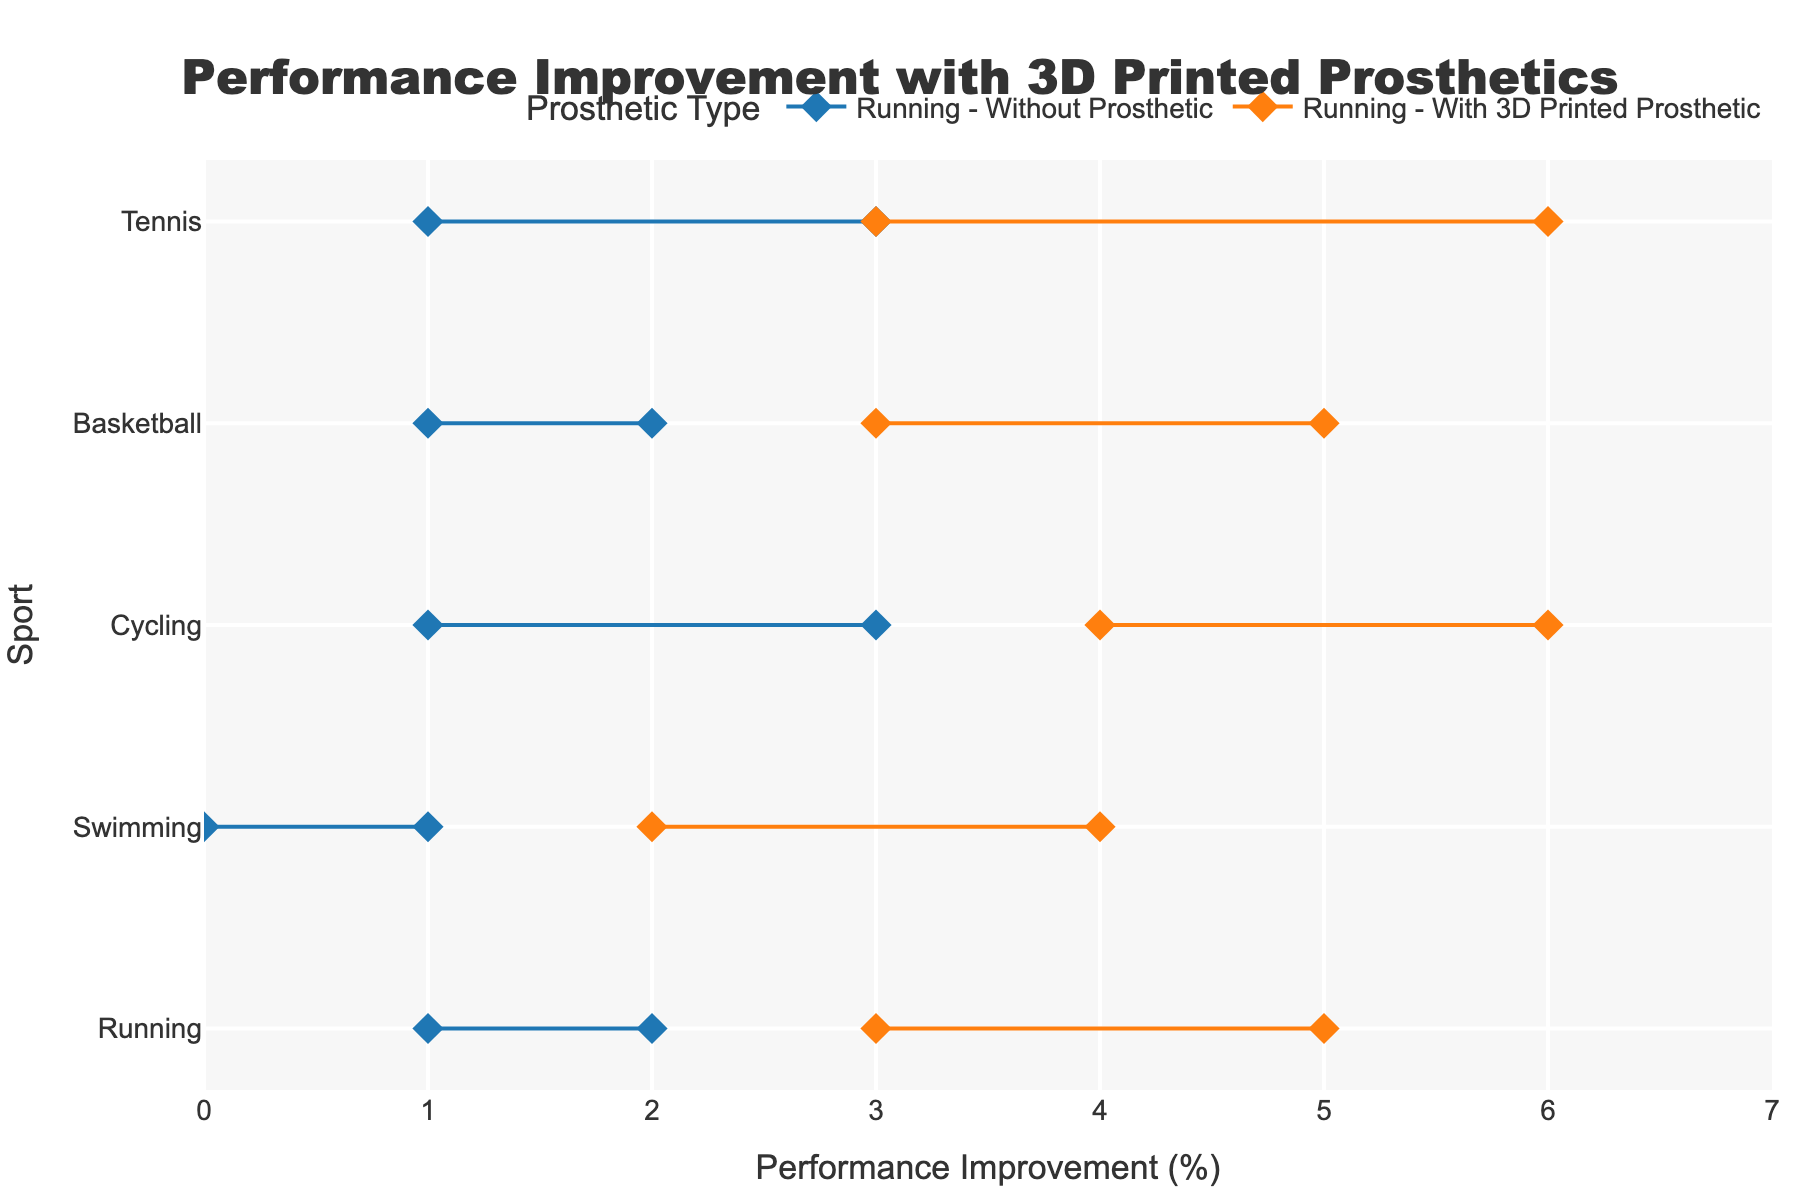What is the title of the figure? The title of the figure is usually located at the top center and provides a summary of what the data represents. In this case, it reads "Performance Improvement with 3D Printed Prosthetics".
Answer: Performance Improvement with 3D Printed Prosthetics What sports are shown in the figure? By looking at the y-axis, we can list all the sports shown. They include Running, Swimming, Cycling, Basketball, and Tennis.
Answer: Running, Swimming, Cycling, Basketball, Tennis For running, what is the range of performance improvement for athletes with 3D printed prosthetics? For Running, locate the orange line with diamond markers on the x-axis corresponding to "With 3D Printed Prosthetic". It spans from 3 to 5.
Answer: 3-5 Which sport shows the least improvement without prosthetics? Find the sport with the smallest range by looking at the blue lines. Swimming shows a range from 0 to 1, which is the smallest.
Answer: Swimming How does the performance improvement for cycling with 3D printed prosthetics compare to without? Look at the lines for Cycling; the orange line (With 3D Printed Prosthetic) ranges from 4 to 6, while the blue line (Without Prosthetic) ranges from 1 to 3. The 3D printed prosthetics show a higher improvement range.
Answer: Higher with 3D printed prosthetics Which sport has the highest maximum improvement with 3D printed prosthetics? Check all the orange lines (With 3D Printed Prosthetic) for the highest value on the x-axis. Tennis has the highest maximum improvement, which is 6.
Answer: Tennis Is there any sport where the minimum improvement with 3D printed prosthetics is higher than the maximum improvement without prosthetics? Compare the minimum values of orange lines to the maximum values of blue lines. For all sports (Running, Swimming, Cycling, Basketball, Tennis), the minimum improvement with 3D printed prosthetics exceeds the maximum improvement without prosthetics.
Answer: Yes What is the average maximum improvement across all sports without prosthetics? Find the maximum improvement values for all blue lines and calculate the average: (2 + 1 + 3 + 2 + 3) / 5 = 2.2
Answer: 2.2 For which sports do 3D printed prosthetics provide a minimum improvement of 3 or more? Look for sports where the minimum value of the orange line is 3 or more. These sports include Running, Basketball, and Tennis.
Answer: Running, Basketball, Tennis How does the range of performance improvement in swimming with 3D printed prosthetics compare to swimming without prosthetics? Swimming with 3D printed prosthetics has a range from 2 to 4 (orange line), while without prosthetics it ranges from 0 to 1 (blue line). The range with 3D printed prosthetics is both higher and wider.
Answer: Higher and wider with 3D printed prosthetics 